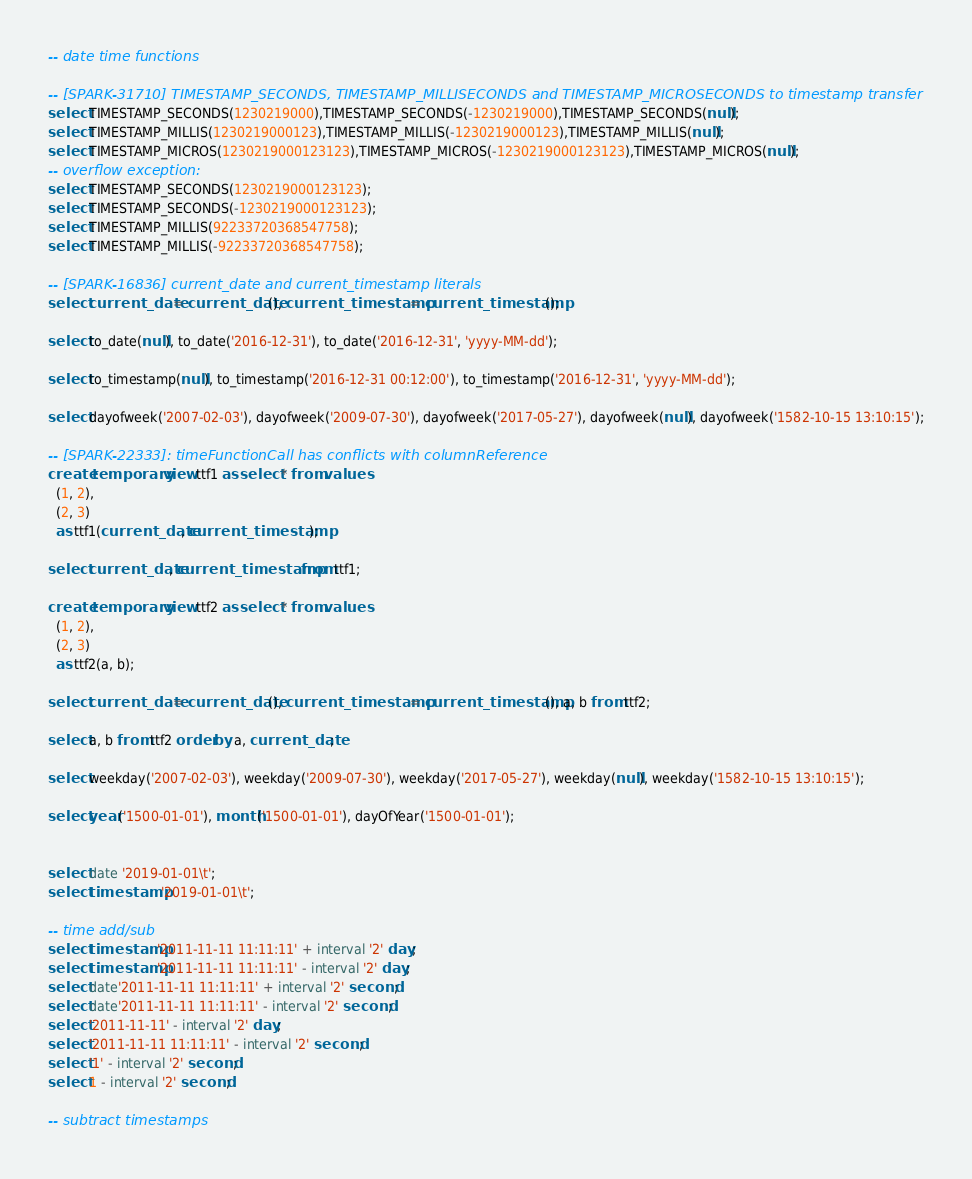Convert code to text. <code><loc_0><loc_0><loc_500><loc_500><_SQL_>-- date time functions

-- [SPARK-31710] TIMESTAMP_SECONDS, TIMESTAMP_MILLISECONDS and TIMESTAMP_MICROSECONDS to timestamp transfer
select TIMESTAMP_SECONDS(1230219000),TIMESTAMP_SECONDS(-1230219000),TIMESTAMP_SECONDS(null);
select TIMESTAMP_MILLIS(1230219000123),TIMESTAMP_MILLIS(-1230219000123),TIMESTAMP_MILLIS(null);
select TIMESTAMP_MICROS(1230219000123123),TIMESTAMP_MICROS(-1230219000123123),TIMESTAMP_MICROS(null);
-- overflow exception:
select TIMESTAMP_SECONDS(1230219000123123);
select TIMESTAMP_SECONDS(-1230219000123123);
select TIMESTAMP_MILLIS(92233720368547758);
select TIMESTAMP_MILLIS(-92233720368547758);

-- [SPARK-16836] current_date and current_timestamp literals
select current_date = current_date(), current_timestamp = current_timestamp();

select to_date(null), to_date('2016-12-31'), to_date('2016-12-31', 'yyyy-MM-dd');

select to_timestamp(null), to_timestamp('2016-12-31 00:12:00'), to_timestamp('2016-12-31', 'yyyy-MM-dd');

select dayofweek('2007-02-03'), dayofweek('2009-07-30'), dayofweek('2017-05-27'), dayofweek(null), dayofweek('1582-10-15 13:10:15');

-- [SPARK-22333]: timeFunctionCall has conflicts with columnReference
create temporary view ttf1 as select * from values
  (1, 2),
  (2, 3)
  as ttf1(current_date, current_timestamp);
  
select current_date, current_timestamp from ttf1;

create temporary view ttf2 as select * from values
  (1, 2),
  (2, 3)
  as ttf2(a, b);
  
select current_date = current_date(), current_timestamp = current_timestamp(), a, b from ttf2;

select a, b from ttf2 order by a, current_date;

select weekday('2007-02-03'), weekday('2009-07-30'), weekday('2017-05-27'), weekday(null), weekday('1582-10-15 13:10:15');

select year('1500-01-01'), month('1500-01-01'), dayOfYear('1500-01-01');


select date '2019-01-01\t';
select timestamp '2019-01-01\t';

-- time add/sub
select timestamp'2011-11-11 11:11:11' + interval '2' day;
select timestamp'2011-11-11 11:11:11' - interval '2' day;
select date'2011-11-11 11:11:11' + interval '2' second;
select date'2011-11-11 11:11:11' - interval '2' second;
select '2011-11-11' - interval '2' day;
select '2011-11-11 11:11:11' - interval '2' second;
select '1' - interval '2' second;
select 1 - interval '2' second;

-- subtract timestamps</code> 